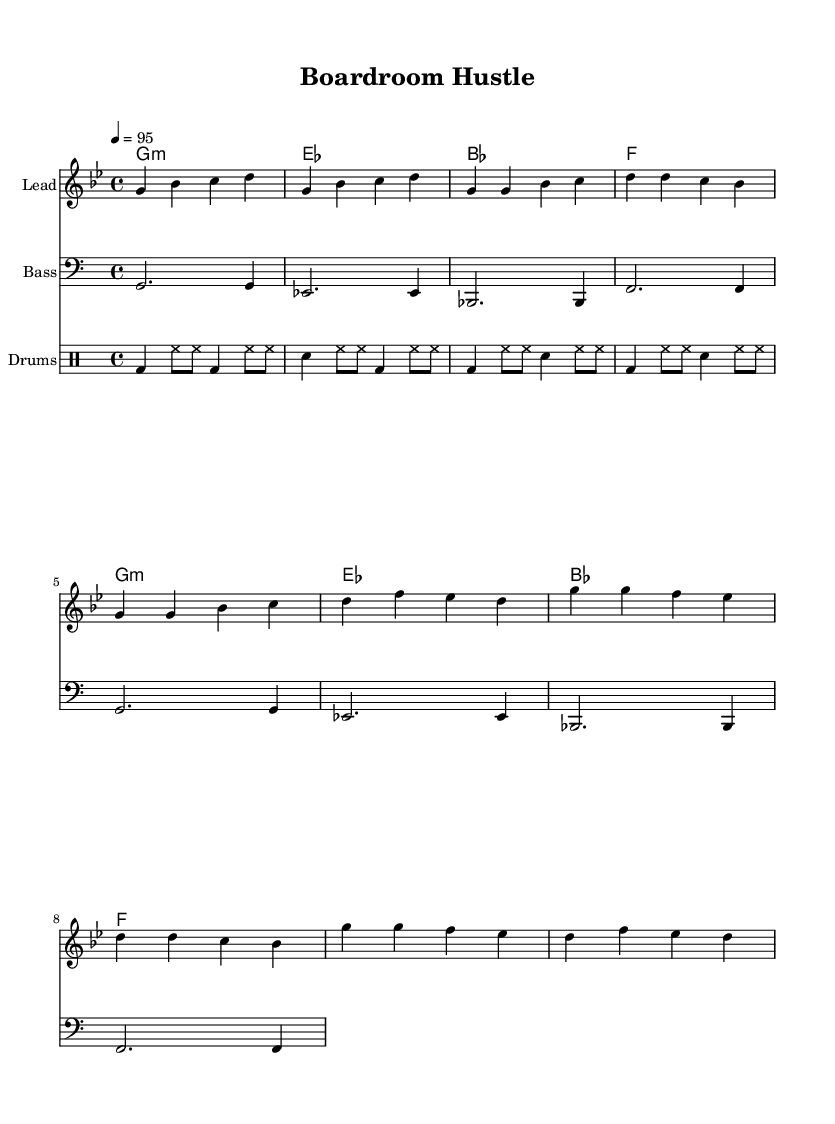What is the key signature of this music? The key signature is G minor, which has two flats. This is determined by the first part of the score, which indicates the key signature along with the notes and chords that conform to this scale.
Answer: G minor What is the time signature of this piece? The time signature is 4/4, found at the beginning of the score. This indicates that there are four beats in each measure and a quarter note receives one beat.
Answer: 4/4 What is the tempo marking for the music? The tempo marking is 95 beats per minute, indicated at the beginning of the score. This provides the speed at which the piece should be played.
Answer: 95 What are the instruments used in this score? The instruments mentioned are Lead, Bass, and Drums, specified in the respective staff headings. This tells us the combination of sounds and parts that will be played.
Answer: Lead, Bass, Drums What type of rhythm is primarily used in the drums part? The drums part primarily uses a combination of bass and hi-hat rhythms, which is a common characteristic in hip hop music. This can be determined by examining the drum notation patterns throughout the score.
Answer: Bass and hi-hat What chord is played during the chorus? The chords during the chorus are G minor, D, and F, as noted in the harmonies section. This reflects the harmonic structure supporting the melody during the chorus.
Answer: G minor, D, F 